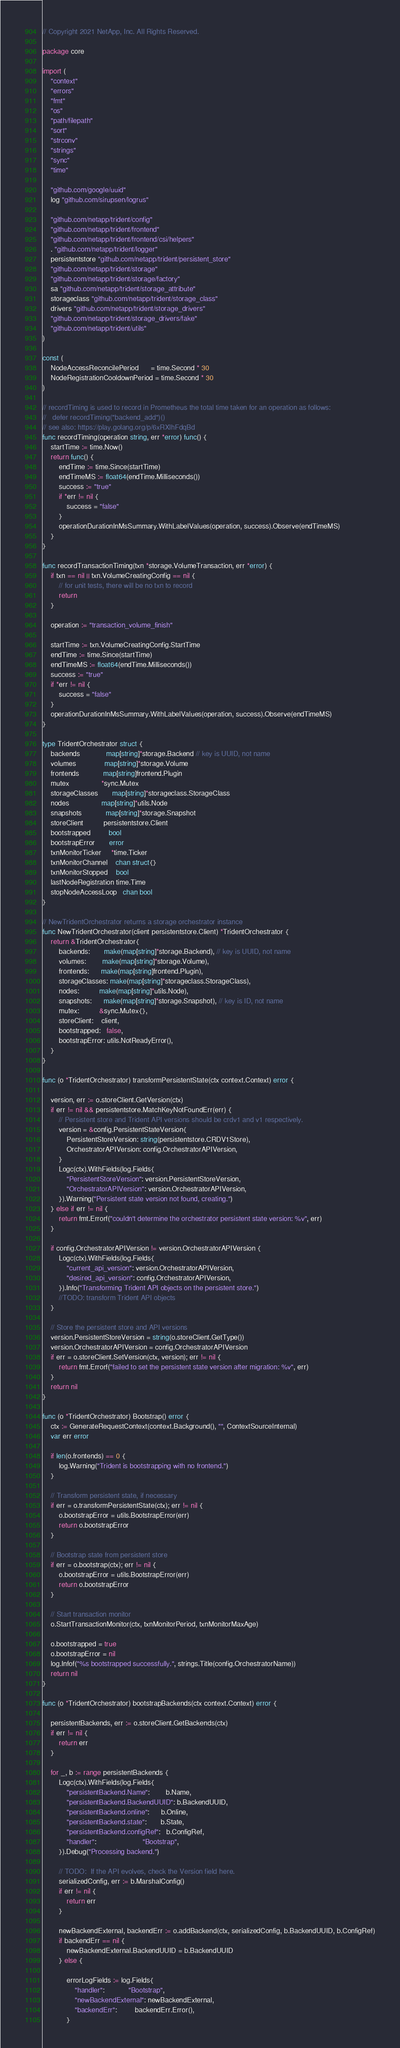<code> <loc_0><loc_0><loc_500><loc_500><_Go_>// Copyright 2021 NetApp, Inc. All Rights Reserved.

package core

import (
	"context"
	"errors"
	"fmt"
	"os"
	"path/filepath"
	"sort"
	"strconv"
	"strings"
	"sync"
	"time"

	"github.com/google/uuid"
	log "github.com/sirupsen/logrus"

	"github.com/netapp/trident/config"
	"github.com/netapp/trident/frontend"
	"github.com/netapp/trident/frontend/csi/helpers"
	. "github.com/netapp/trident/logger"
	persistentstore "github.com/netapp/trident/persistent_store"
	"github.com/netapp/trident/storage"
	"github.com/netapp/trident/storage/factory"
	sa "github.com/netapp/trident/storage_attribute"
	storageclass "github.com/netapp/trident/storage_class"
	drivers "github.com/netapp/trident/storage_drivers"
	"github.com/netapp/trident/storage_drivers/fake"
	"github.com/netapp/trident/utils"
)

const (
	NodeAccessReconcilePeriod      = time.Second * 30
	NodeRegistrationCooldownPeriod = time.Second * 30
)

// recordTiming is used to record in Prometheus the total time taken for an operation as follows:
//   defer recordTiming("backend_add")()
// see also: https://play.golang.org/p/6xRXlhFdqBd
func recordTiming(operation string, err *error) func() {
	startTime := time.Now()
	return func() {
		endTime := time.Since(startTime)
		endTimeMS := float64(endTime.Milliseconds())
		success := "true"
		if *err != nil {
			success = "false"
		}
		operationDurationInMsSummary.WithLabelValues(operation, success).Observe(endTimeMS)
	}
}

func recordTransactionTiming(txn *storage.VolumeTransaction, err *error) {
	if txn == nil || txn.VolumeCreatingConfig == nil {
		// for unit tests, there will be no txn to record
		return
	}

	operation := "transaction_volume_finish"

	startTime := txn.VolumeCreatingConfig.StartTime
	endTime := time.Since(startTime)
	endTimeMS := float64(endTime.Milliseconds())
	success := "true"
	if *err != nil {
		success = "false"
	}
	operationDurationInMsSummary.WithLabelValues(operation, success).Observe(endTimeMS)
}

type TridentOrchestrator struct {
	backends             map[string]*storage.Backend // key is UUID, not name
	volumes              map[string]*storage.Volume
	frontends            map[string]frontend.Plugin
	mutex                *sync.Mutex
	storageClasses       map[string]*storageclass.StorageClass
	nodes                map[string]*utils.Node
	snapshots            map[string]*storage.Snapshot
	storeClient          persistentstore.Client
	bootstrapped         bool
	bootstrapError       error
	txnMonitorTicker     *time.Ticker
	txnMonitorChannel    chan struct{}
	txnMonitorStopped    bool
	lastNodeRegistration time.Time
	stopNodeAccessLoop   chan bool
}

// NewTridentOrchestrator returns a storage orchestrator instance
func NewTridentOrchestrator(client persistentstore.Client) *TridentOrchestrator {
	return &TridentOrchestrator{
		backends:       make(map[string]*storage.Backend), // key is UUID, not name
		volumes:        make(map[string]*storage.Volume),
		frontends:      make(map[string]frontend.Plugin),
		storageClasses: make(map[string]*storageclass.StorageClass),
		nodes:          make(map[string]*utils.Node),
		snapshots:      make(map[string]*storage.Snapshot), // key is ID, not name
		mutex:          &sync.Mutex{},
		storeClient:    client,
		bootstrapped:   false,
		bootstrapError: utils.NotReadyError(),
	}
}

func (o *TridentOrchestrator) transformPersistentState(ctx context.Context) error {

	version, err := o.storeClient.GetVersion(ctx)
	if err != nil && persistentstore.MatchKeyNotFoundErr(err) {
		// Persistent store and Trident API versions should be crdv1 and v1 respectively.
		version = &config.PersistentStateVersion{
			PersistentStoreVersion: string(persistentstore.CRDV1Store),
			OrchestratorAPIVersion: config.OrchestratorAPIVersion,
		}
		Logc(ctx).WithFields(log.Fields{
			"PersistentStoreVersion": version.PersistentStoreVersion,
			"OrchestratorAPIVersion": version.OrchestratorAPIVersion,
		}).Warning("Persistent state version not found, creating.")
	} else if err != nil {
		return fmt.Errorf("couldn't determine the orchestrator persistent state version: %v", err)
	}

	if config.OrchestratorAPIVersion != version.OrchestratorAPIVersion {
		Logc(ctx).WithFields(log.Fields{
			"current_api_version": version.OrchestratorAPIVersion,
			"desired_api_version": config.OrchestratorAPIVersion,
		}).Info("Transforming Trident API objects on the persistent store.")
		//TODO: transform Trident API objects
	}

	// Store the persistent store and API versions
	version.PersistentStoreVersion = string(o.storeClient.GetType())
	version.OrchestratorAPIVersion = config.OrchestratorAPIVersion
	if err = o.storeClient.SetVersion(ctx, version); err != nil {
		return fmt.Errorf("failed to set the persistent state version after migration: %v", err)
	}
	return nil
}

func (o *TridentOrchestrator) Bootstrap() error {
	ctx := GenerateRequestContext(context.Background(), "", ContextSourceInternal)
	var err error

	if len(o.frontends) == 0 {
		log.Warning("Trident is bootstrapping with no frontend.")
	}

	// Transform persistent state, if necessary
	if err = o.transformPersistentState(ctx); err != nil {
		o.bootstrapError = utils.BootstrapError(err)
		return o.bootstrapError
	}

	// Bootstrap state from persistent store
	if err = o.bootstrap(ctx); err != nil {
		o.bootstrapError = utils.BootstrapError(err)
		return o.bootstrapError
	}

	// Start transaction monitor
	o.StartTransactionMonitor(ctx, txnMonitorPeriod, txnMonitorMaxAge)

	o.bootstrapped = true
	o.bootstrapError = nil
	log.Infof("%s bootstrapped successfully.", strings.Title(config.OrchestratorName))
	return nil
}

func (o *TridentOrchestrator) bootstrapBackends(ctx context.Context) error {

	persistentBackends, err := o.storeClient.GetBackends(ctx)
	if err != nil {
		return err
	}

	for _, b := range persistentBackends {
		Logc(ctx).WithFields(log.Fields{
			"persistentBackend.Name":        b.Name,
			"persistentBackend.BackendUUID": b.BackendUUID,
			"persistentBackend.online":      b.Online,
			"persistentBackend.state":       b.State,
			"persistentBackend.configRef":   b.ConfigRef,
			"handler":                       "Bootstrap",
		}).Debug("Processing backend.")

		// TODO:  If the API evolves, check the Version field here.
		serializedConfig, err := b.MarshalConfig()
		if err != nil {
			return err
		}

		newBackendExternal, backendErr := o.addBackend(ctx, serializedConfig, b.BackendUUID, b.ConfigRef)
		if backendErr == nil {
			newBackendExternal.BackendUUID = b.BackendUUID
		} else {

			errorLogFields := log.Fields{
				"handler":            "Bootstrap",
				"newBackendExternal": newBackendExternal,
				"backendErr":         backendErr.Error(),
			}
</code> 